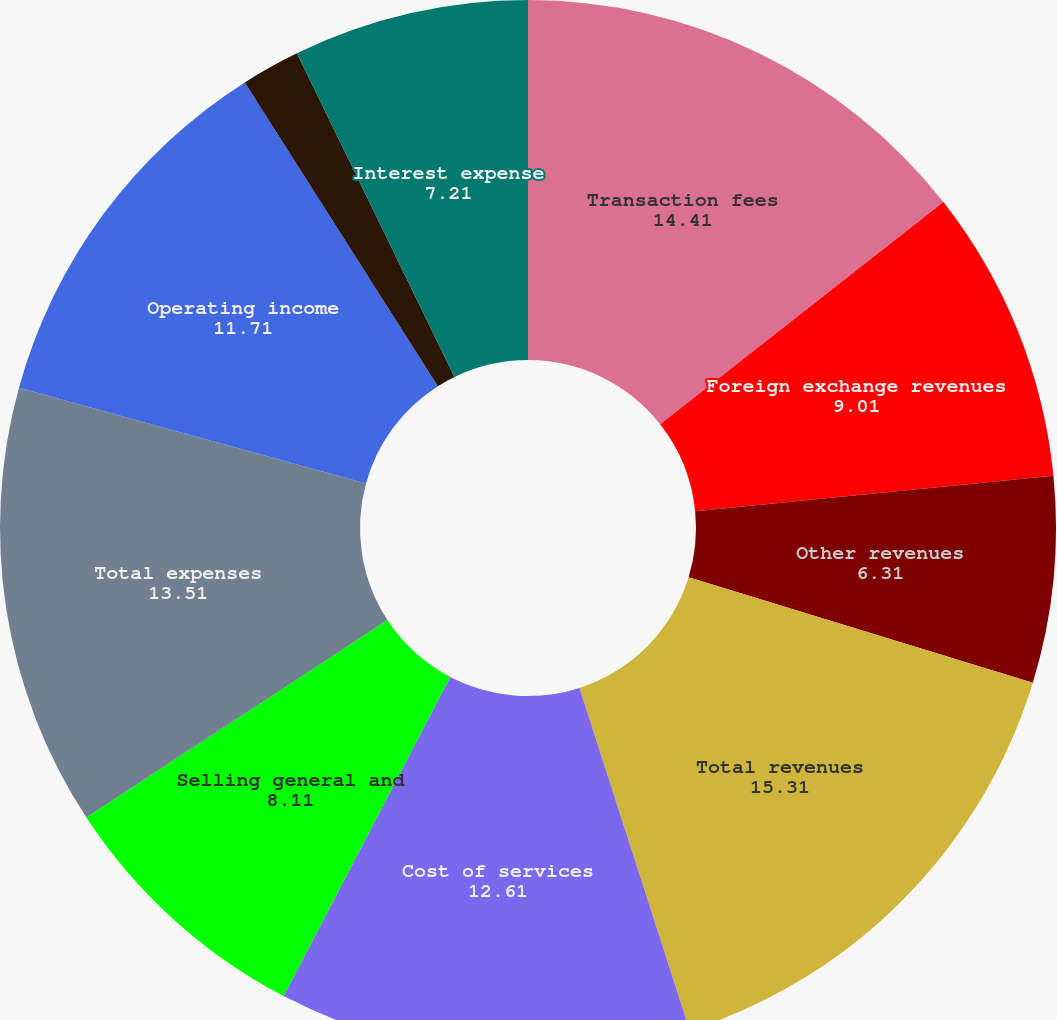<chart> <loc_0><loc_0><loc_500><loc_500><pie_chart><fcel>Transaction fees<fcel>Foreign exchange revenues<fcel>Other revenues<fcel>Total revenues<fcel>Cost of services<fcel>Selling general and<fcel>Total expenses<fcel>Operating income<fcel>Interest income<fcel>Interest expense<nl><fcel>14.41%<fcel>9.01%<fcel>6.31%<fcel>15.31%<fcel>12.61%<fcel>8.11%<fcel>13.51%<fcel>11.71%<fcel>1.8%<fcel>7.21%<nl></chart> 